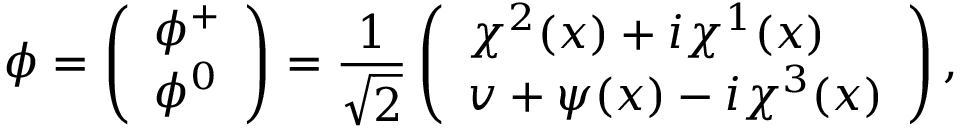<formula> <loc_0><loc_0><loc_500><loc_500>\phi = \left ( \begin{array} { l } { { \phi ^ { + } } } \\ { { \phi ^ { 0 } } } \end{array} \right ) = \frac { 1 } { \sqrt { 2 } } \left ( \begin{array} { l } { { \chi ^ { 2 } ( x ) + i \chi ^ { 1 } ( x ) } } \\ { { v + \psi ( x ) - i \chi ^ { 3 } ( x ) } } \end{array} \right ) ,</formula> 